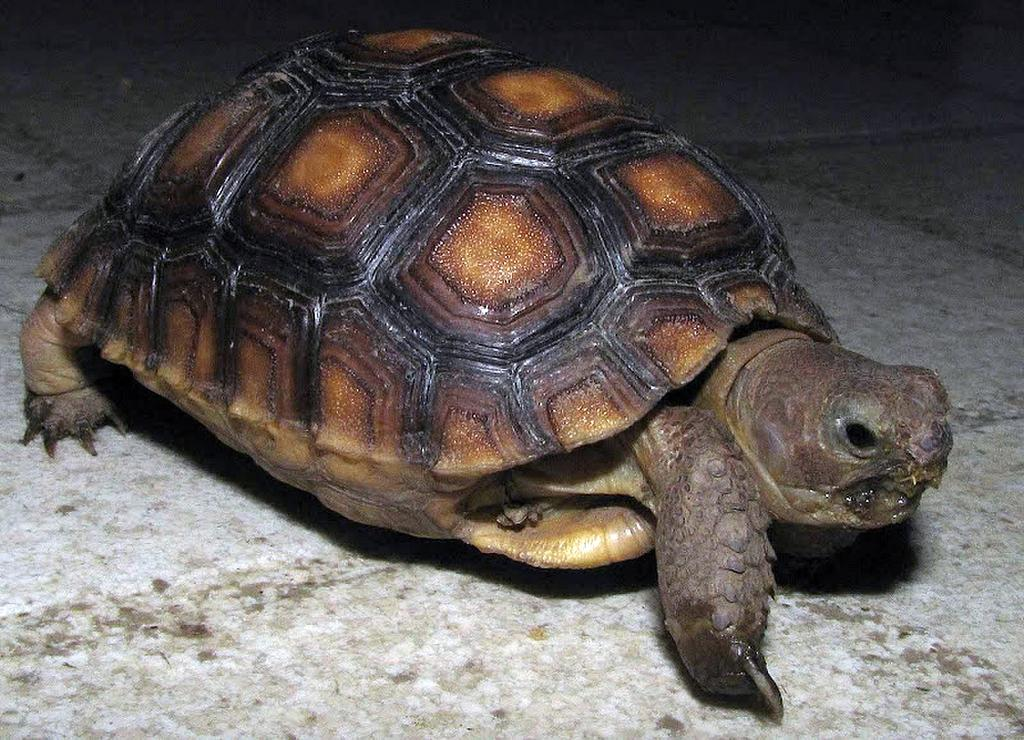What type of animal is in the image? There is a tortoise in the image. Where is the tortoise located in the image? The tortoise is on the floor. What type of celery is the tortoise eating in the image? There is no celery present in the image, and the tortoise is not eating anything. 